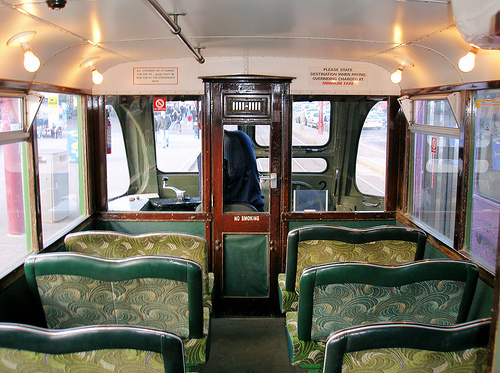<image>
Is there a seat under the mirror? No. The seat is not positioned under the mirror. The vertical relationship between these objects is different. 